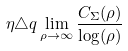<formula> <loc_0><loc_0><loc_500><loc_500>\eta \triangle q \lim _ { \rho \rightarrow \infty } \frac { C _ { \Sigma } ( \rho ) } { \log ( \rho ) }</formula> 